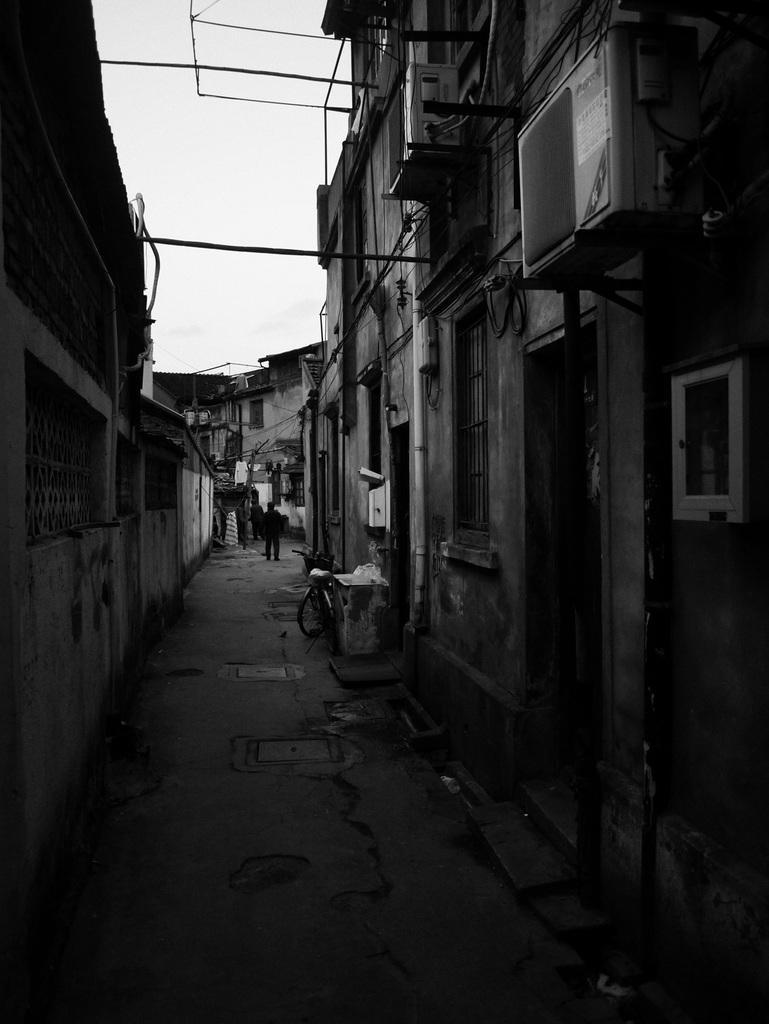How would you summarize this image in a sentence or two? This is a black and white image in this image we could see some buildings, air conditioners, pipes and some vehicles and some people are walking. At the bottom there is a walkway, and at the top there are some poles and sky. 